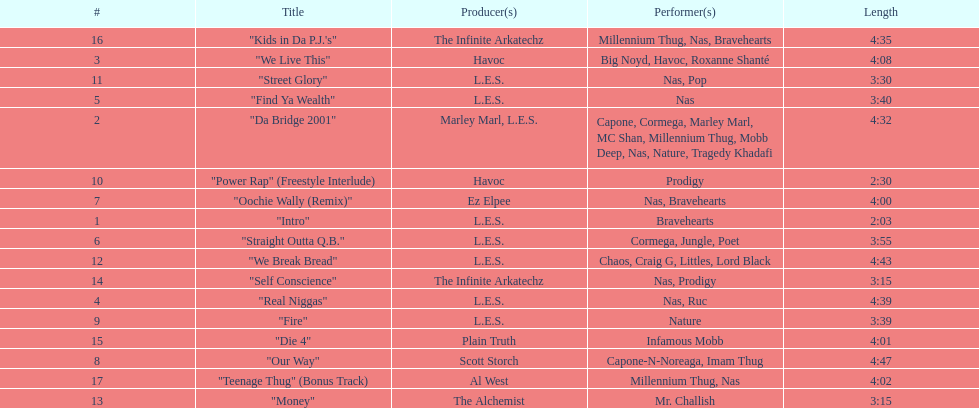Who produced the last track of the album? Al West. 